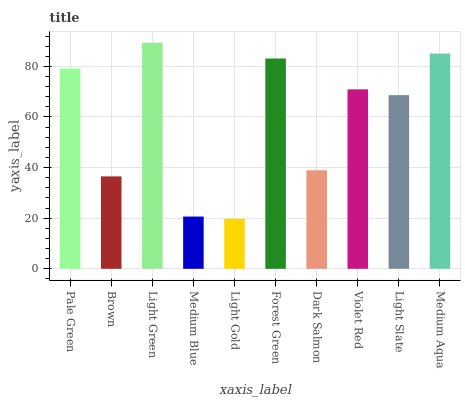Is Light Gold the minimum?
Answer yes or no. Yes. Is Light Green the maximum?
Answer yes or no. Yes. Is Brown the minimum?
Answer yes or no. No. Is Brown the maximum?
Answer yes or no. No. Is Pale Green greater than Brown?
Answer yes or no. Yes. Is Brown less than Pale Green?
Answer yes or no. Yes. Is Brown greater than Pale Green?
Answer yes or no. No. Is Pale Green less than Brown?
Answer yes or no. No. Is Violet Red the high median?
Answer yes or no. Yes. Is Light Slate the low median?
Answer yes or no. Yes. Is Dark Salmon the high median?
Answer yes or no. No. Is Pale Green the low median?
Answer yes or no. No. 